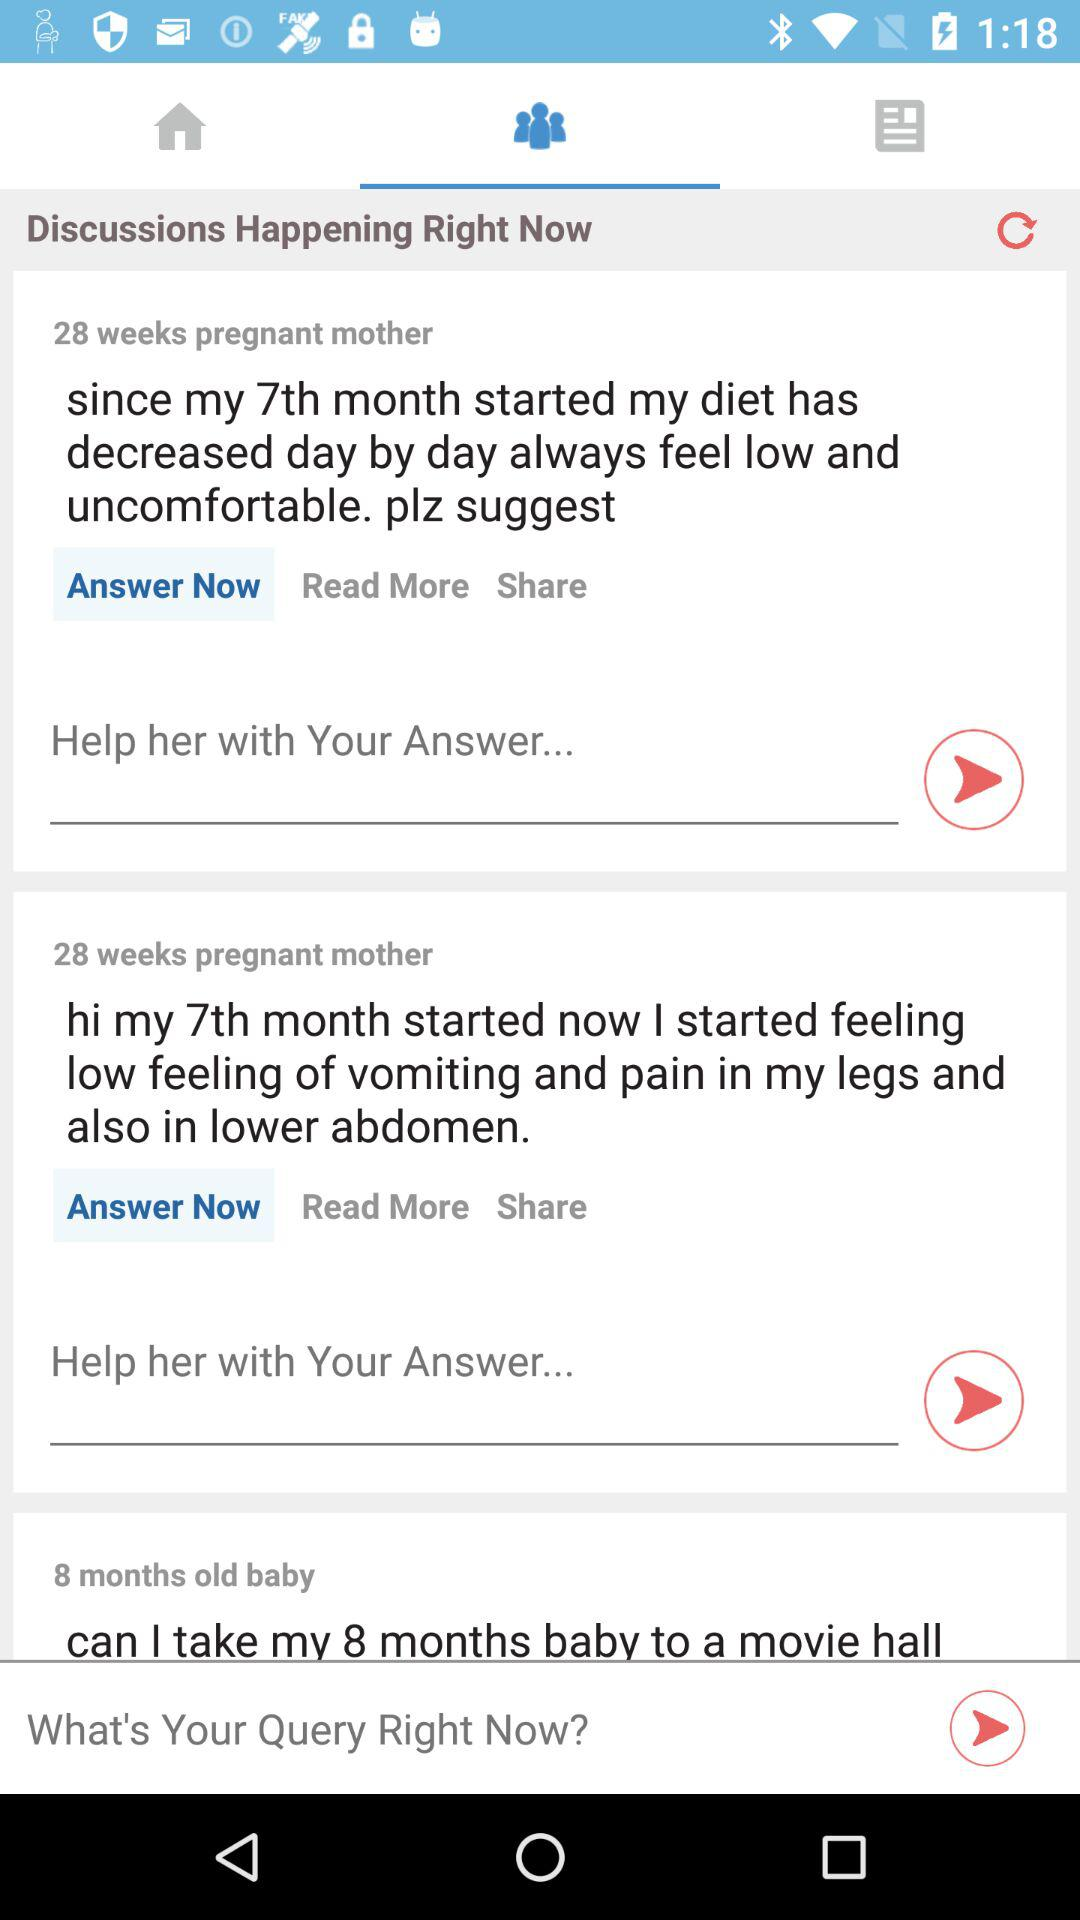Which tab is selected? The selected tab is "Group". 